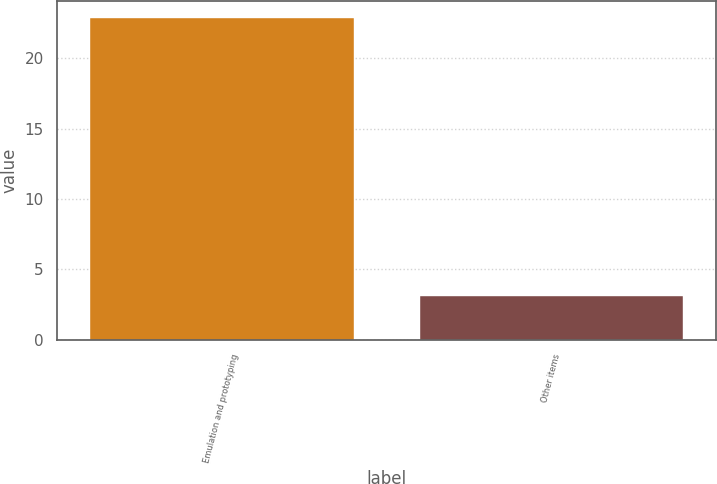<chart> <loc_0><loc_0><loc_500><loc_500><bar_chart><fcel>Emulation and prototyping<fcel>Other items<nl><fcel>22.9<fcel>3.1<nl></chart> 